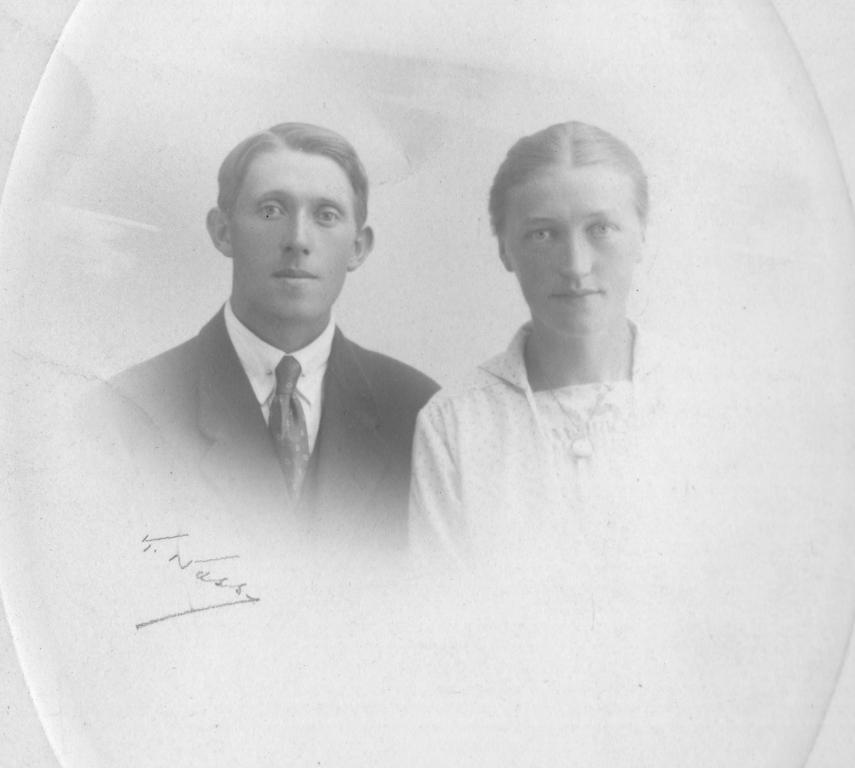Can you describe this image briefly? This image looks like it is edited. There are two persons. On the left, the man is wearing a black suit. On the right, the woman is wearing a white dress. And we can see a signature near the man. 